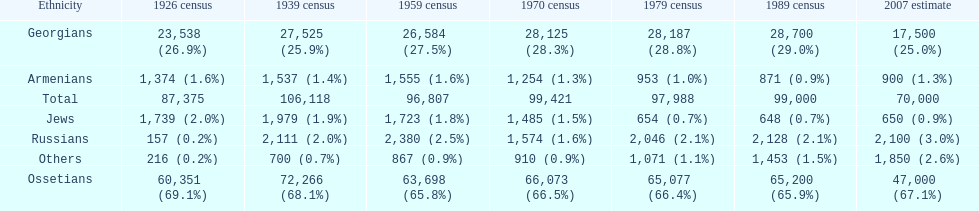Which population had the most people in 1926? Ossetians. Would you be able to parse every entry in this table? {'header': ['Ethnicity', '1926 census', '1939 census', '1959 census', '1970 census', '1979 census', '1989 census', '2007 estimate'], 'rows': [['Georgians', '23,538 (26.9%)', '27,525 (25.9%)', '26,584 (27.5%)', '28,125 (28.3%)', '28,187 (28.8%)', '28,700 (29.0%)', '17,500 (25.0%)'], ['Armenians', '1,374 (1.6%)', '1,537 (1.4%)', '1,555 (1.6%)', '1,254 (1.3%)', '953 (1.0%)', '871 (0.9%)', '900 (1.3%)'], ['Total', '87,375', '106,118', '96,807', '99,421', '97,988', '99,000', '70,000'], ['Jews', '1,739 (2.0%)', '1,979 (1.9%)', '1,723 (1.8%)', '1,485 (1.5%)', '654 (0.7%)', '648 (0.7%)', '650 (0.9%)'], ['Russians', '157 (0.2%)', '2,111 (2.0%)', '2,380 (2.5%)', '1,574 (1.6%)', '2,046 (2.1%)', '2,128 (2.1%)', '2,100 (3.0%)'], ['Others', '216 (0.2%)', '700 (0.7%)', '867 (0.9%)', '910 (0.9%)', '1,071 (1.1%)', '1,453 (1.5%)', '1,850 (2.6%)'], ['Ossetians', '60,351 (69.1%)', '72,266 (68.1%)', '63,698 (65.8%)', '66,073 (66.5%)', '65,077 (66.4%)', '65,200 (65.9%)', '47,000 (67.1%)']]} 